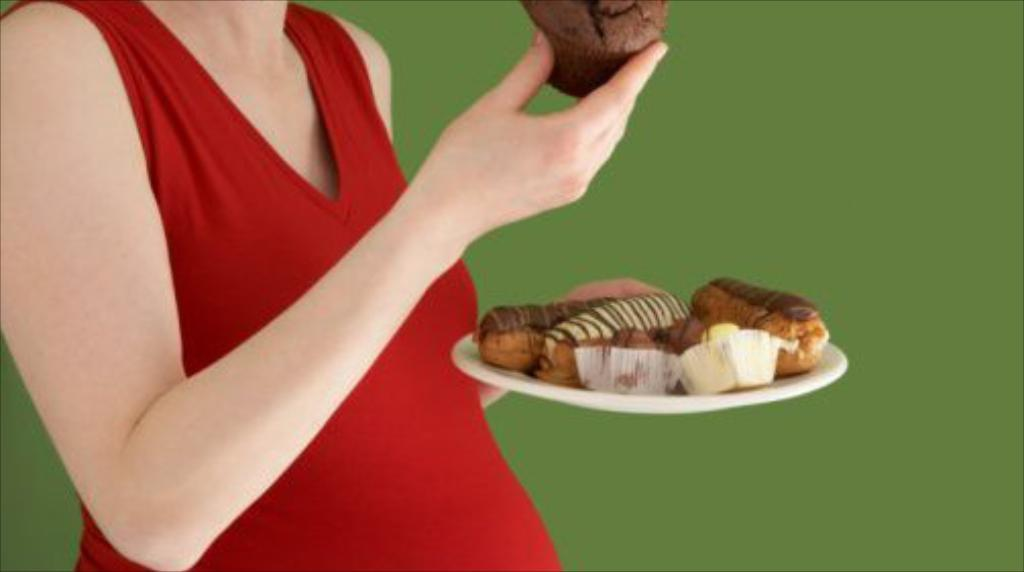Who is the main subject in the image? There is a lady in the image. What is the lady wearing? The lady is wearing a red dress. What is the lady holding in the image? The lady is holding a plate. What is on the plate that the lady is holding? The plate contains cupcakes and other cakes. What can be seen in the background of the image? There is a green wall in the background of the image. What type of stew is being served on the plate in the image? There is no stew present in the image; the plate contains cupcakes and other cakes. Can you see a snail crawling on the lady's red dress in the image? There is no snail visible on the lady's red dress in the image. 